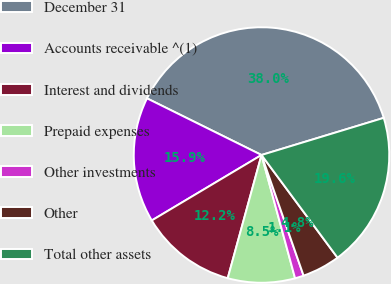Convert chart. <chart><loc_0><loc_0><loc_500><loc_500><pie_chart><fcel>December 31<fcel>Accounts receivable ^(1)<fcel>Interest and dividends<fcel>Prepaid expenses<fcel>Other investments<fcel>Other<fcel>Total other assets<nl><fcel>37.99%<fcel>15.87%<fcel>12.18%<fcel>8.49%<fcel>1.11%<fcel>4.8%<fcel>19.55%<nl></chart> 